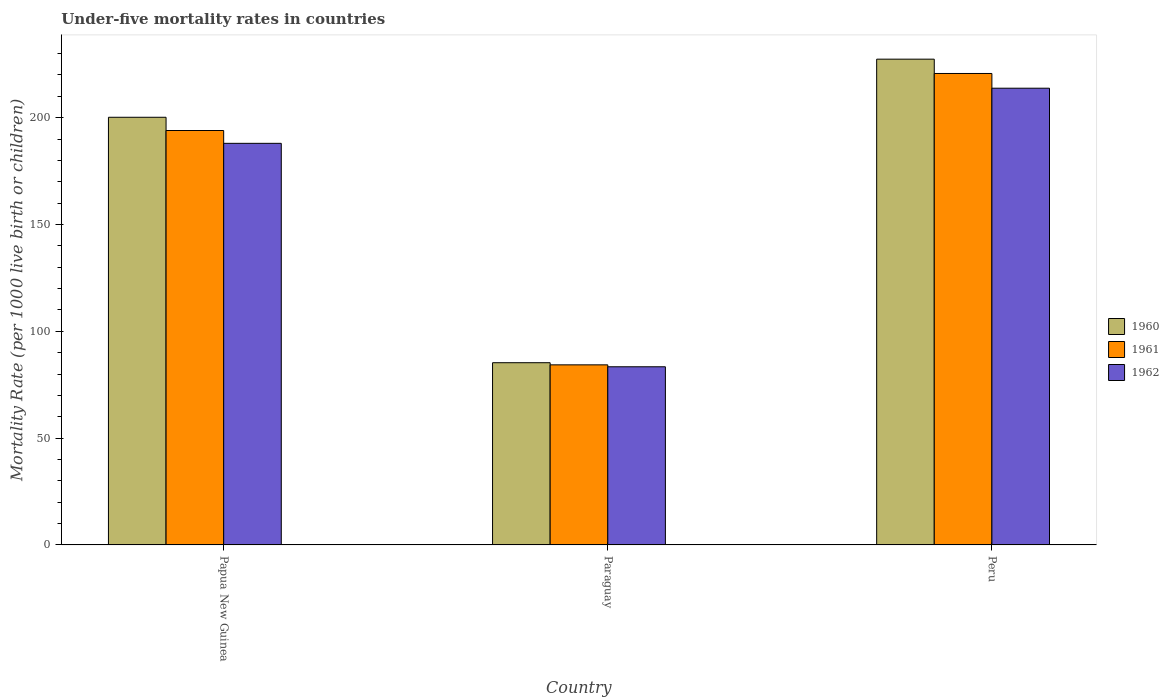How many different coloured bars are there?
Keep it short and to the point. 3. Are the number of bars per tick equal to the number of legend labels?
Offer a terse response. Yes. How many bars are there on the 1st tick from the left?
Give a very brief answer. 3. What is the label of the 1st group of bars from the left?
Ensure brevity in your answer.  Papua New Guinea. In how many cases, is the number of bars for a given country not equal to the number of legend labels?
Give a very brief answer. 0. What is the under-five mortality rate in 1962 in Paraguay?
Provide a succinct answer. 83.4. Across all countries, what is the maximum under-five mortality rate in 1960?
Give a very brief answer. 227.4. Across all countries, what is the minimum under-five mortality rate in 1962?
Ensure brevity in your answer.  83.4. In which country was the under-five mortality rate in 1961 maximum?
Provide a short and direct response. Peru. In which country was the under-five mortality rate in 1960 minimum?
Make the answer very short. Paraguay. What is the total under-five mortality rate in 1961 in the graph?
Your answer should be very brief. 499. What is the difference between the under-five mortality rate in 1960 in Papua New Guinea and that in Paraguay?
Ensure brevity in your answer.  114.9. What is the difference between the under-five mortality rate in 1960 in Peru and the under-five mortality rate in 1961 in Paraguay?
Offer a terse response. 143.1. What is the average under-five mortality rate in 1960 per country?
Ensure brevity in your answer.  170.97. What is the difference between the under-five mortality rate of/in 1962 and under-five mortality rate of/in 1961 in Papua New Guinea?
Your response must be concise. -6. In how many countries, is the under-five mortality rate in 1961 greater than 120?
Your answer should be very brief. 2. What is the ratio of the under-five mortality rate in 1962 in Papua New Guinea to that in Peru?
Your response must be concise. 0.88. Is the under-five mortality rate in 1962 in Papua New Guinea less than that in Paraguay?
Your answer should be very brief. No. What is the difference between the highest and the second highest under-five mortality rate in 1962?
Provide a succinct answer. -104.6. What is the difference between the highest and the lowest under-five mortality rate in 1962?
Your response must be concise. 130.4. In how many countries, is the under-five mortality rate in 1960 greater than the average under-five mortality rate in 1960 taken over all countries?
Offer a very short reply. 2. What does the 3rd bar from the right in Papua New Guinea represents?
Ensure brevity in your answer.  1960. Is it the case that in every country, the sum of the under-five mortality rate in 1960 and under-five mortality rate in 1961 is greater than the under-five mortality rate in 1962?
Offer a very short reply. Yes. How many bars are there?
Keep it short and to the point. 9. How many countries are there in the graph?
Keep it short and to the point. 3. What is the difference between two consecutive major ticks on the Y-axis?
Give a very brief answer. 50. Does the graph contain any zero values?
Make the answer very short. No. Does the graph contain grids?
Provide a short and direct response. No. How many legend labels are there?
Offer a very short reply. 3. What is the title of the graph?
Offer a very short reply. Under-five mortality rates in countries. Does "2013" appear as one of the legend labels in the graph?
Keep it short and to the point. No. What is the label or title of the X-axis?
Provide a short and direct response. Country. What is the label or title of the Y-axis?
Offer a very short reply. Mortality Rate (per 1000 live birth or children). What is the Mortality Rate (per 1000 live birth or children) in 1960 in Papua New Guinea?
Provide a succinct answer. 200.2. What is the Mortality Rate (per 1000 live birth or children) in 1961 in Papua New Guinea?
Your answer should be compact. 194. What is the Mortality Rate (per 1000 live birth or children) of 1962 in Papua New Guinea?
Your answer should be compact. 188. What is the Mortality Rate (per 1000 live birth or children) in 1960 in Paraguay?
Your response must be concise. 85.3. What is the Mortality Rate (per 1000 live birth or children) of 1961 in Paraguay?
Provide a short and direct response. 84.3. What is the Mortality Rate (per 1000 live birth or children) in 1962 in Paraguay?
Your response must be concise. 83.4. What is the Mortality Rate (per 1000 live birth or children) of 1960 in Peru?
Ensure brevity in your answer.  227.4. What is the Mortality Rate (per 1000 live birth or children) of 1961 in Peru?
Keep it short and to the point. 220.7. What is the Mortality Rate (per 1000 live birth or children) of 1962 in Peru?
Your answer should be very brief. 213.8. Across all countries, what is the maximum Mortality Rate (per 1000 live birth or children) of 1960?
Offer a very short reply. 227.4. Across all countries, what is the maximum Mortality Rate (per 1000 live birth or children) of 1961?
Provide a succinct answer. 220.7. Across all countries, what is the maximum Mortality Rate (per 1000 live birth or children) of 1962?
Make the answer very short. 213.8. Across all countries, what is the minimum Mortality Rate (per 1000 live birth or children) in 1960?
Provide a succinct answer. 85.3. Across all countries, what is the minimum Mortality Rate (per 1000 live birth or children) of 1961?
Offer a terse response. 84.3. Across all countries, what is the minimum Mortality Rate (per 1000 live birth or children) of 1962?
Keep it short and to the point. 83.4. What is the total Mortality Rate (per 1000 live birth or children) in 1960 in the graph?
Offer a terse response. 512.9. What is the total Mortality Rate (per 1000 live birth or children) of 1961 in the graph?
Offer a terse response. 499. What is the total Mortality Rate (per 1000 live birth or children) in 1962 in the graph?
Offer a terse response. 485.2. What is the difference between the Mortality Rate (per 1000 live birth or children) in 1960 in Papua New Guinea and that in Paraguay?
Your answer should be compact. 114.9. What is the difference between the Mortality Rate (per 1000 live birth or children) in 1961 in Papua New Guinea and that in Paraguay?
Make the answer very short. 109.7. What is the difference between the Mortality Rate (per 1000 live birth or children) in 1962 in Papua New Guinea and that in Paraguay?
Your response must be concise. 104.6. What is the difference between the Mortality Rate (per 1000 live birth or children) of 1960 in Papua New Guinea and that in Peru?
Provide a succinct answer. -27.2. What is the difference between the Mortality Rate (per 1000 live birth or children) in 1961 in Papua New Guinea and that in Peru?
Offer a very short reply. -26.7. What is the difference between the Mortality Rate (per 1000 live birth or children) of 1962 in Papua New Guinea and that in Peru?
Give a very brief answer. -25.8. What is the difference between the Mortality Rate (per 1000 live birth or children) in 1960 in Paraguay and that in Peru?
Provide a short and direct response. -142.1. What is the difference between the Mortality Rate (per 1000 live birth or children) in 1961 in Paraguay and that in Peru?
Your answer should be very brief. -136.4. What is the difference between the Mortality Rate (per 1000 live birth or children) in 1962 in Paraguay and that in Peru?
Make the answer very short. -130.4. What is the difference between the Mortality Rate (per 1000 live birth or children) in 1960 in Papua New Guinea and the Mortality Rate (per 1000 live birth or children) in 1961 in Paraguay?
Offer a very short reply. 115.9. What is the difference between the Mortality Rate (per 1000 live birth or children) in 1960 in Papua New Guinea and the Mortality Rate (per 1000 live birth or children) in 1962 in Paraguay?
Your answer should be compact. 116.8. What is the difference between the Mortality Rate (per 1000 live birth or children) in 1961 in Papua New Guinea and the Mortality Rate (per 1000 live birth or children) in 1962 in Paraguay?
Keep it short and to the point. 110.6. What is the difference between the Mortality Rate (per 1000 live birth or children) in 1960 in Papua New Guinea and the Mortality Rate (per 1000 live birth or children) in 1961 in Peru?
Make the answer very short. -20.5. What is the difference between the Mortality Rate (per 1000 live birth or children) in 1961 in Papua New Guinea and the Mortality Rate (per 1000 live birth or children) in 1962 in Peru?
Keep it short and to the point. -19.8. What is the difference between the Mortality Rate (per 1000 live birth or children) in 1960 in Paraguay and the Mortality Rate (per 1000 live birth or children) in 1961 in Peru?
Give a very brief answer. -135.4. What is the difference between the Mortality Rate (per 1000 live birth or children) in 1960 in Paraguay and the Mortality Rate (per 1000 live birth or children) in 1962 in Peru?
Ensure brevity in your answer.  -128.5. What is the difference between the Mortality Rate (per 1000 live birth or children) of 1961 in Paraguay and the Mortality Rate (per 1000 live birth or children) of 1962 in Peru?
Offer a very short reply. -129.5. What is the average Mortality Rate (per 1000 live birth or children) in 1960 per country?
Make the answer very short. 170.97. What is the average Mortality Rate (per 1000 live birth or children) in 1961 per country?
Keep it short and to the point. 166.33. What is the average Mortality Rate (per 1000 live birth or children) in 1962 per country?
Offer a very short reply. 161.73. What is the difference between the Mortality Rate (per 1000 live birth or children) in 1960 and Mortality Rate (per 1000 live birth or children) in 1961 in Paraguay?
Give a very brief answer. 1. What is the difference between the Mortality Rate (per 1000 live birth or children) in 1960 and Mortality Rate (per 1000 live birth or children) in 1962 in Paraguay?
Make the answer very short. 1.9. What is the difference between the Mortality Rate (per 1000 live birth or children) in 1960 and Mortality Rate (per 1000 live birth or children) in 1961 in Peru?
Make the answer very short. 6.7. What is the difference between the Mortality Rate (per 1000 live birth or children) in 1960 and Mortality Rate (per 1000 live birth or children) in 1962 in Peru?
Your answer should be very brief. 13.6. What is the ratio of the Mortality Rate (per 1000 live birth or children) of 1960 in Papua New Guinea to that in Paraguay?
Offer a very short reply. 2.35. What is the ratio of the Mortality Rate (per 1000 live birth or children) in 1961 in Papua New Guinea to that in Paraguay?
Give a very brief answer. 2.3. What is the ratio of the Mortality Rate (per 1000 live birth or children) in 1962 in Papua New Guinea to that in Paraguay?
Give a very brief answer. 2.25. What is the ratio of the Mortality Rate (per 1000 live birth or children) in 1960 in Papua New Guinea to that in Peru?
Keep it short and to the point. 0.88. What is the ratio of the Mortality Rate (per 1000 live birth or children) in 1961 in Papua New Guinea to that in Peru?
Your answer should be compact. 0.88. What is the ratio of the Mortality Rate (per 1000 live birth or children) of 1962 in Papua New Guinea to that in Peru?
Provide a short and direct response. 0.88. What is the ratio of the Mortality Rate (per 1000 live birth or children) of 1960 in Paraguay to that in Peru?
Provide a succinct answer. 0.38. What is the ratio of the Mortality Rate (per 1000 live birth or children) in 1961 in Paraguay to that in Peru?
Ensure brevity in your answer.  0.38. What is the ratio of the Mortality Rate (per 1000 live birth or children) in 1962 in Paraguay to that in Peru?
Offer a terse response. 0.39. What is the difference between the highest and the second highest Mortality Rate (per 1000 live birth or children) of 1960?
Ensure brevity in your answer.  27.2. What is the difference between the highest and the second highest Mortality Rate (per 1000 live birth or children) in 1961?
Provide a short and direct response. 26.7. What is the difference between the highest and the second highest Mortality Rate (per 1000 live birth or children) of 1962?
Provide a succinct answer. 25.8. What is the difference between the highest and the lowest Mortality Rate (per 1000 live birth or children) of 1960?
Offer a terse response. 142.1. What is the difference between the highest and the lowest Mortality Rate (per 1000 live birth or children) of 1961?
Your answer should be compact. 136.4. What is the difference between the highest and the lowest Mortality Rate (per 1000 live birth or children) in 1962?
Your response must be concise. 130.4. 